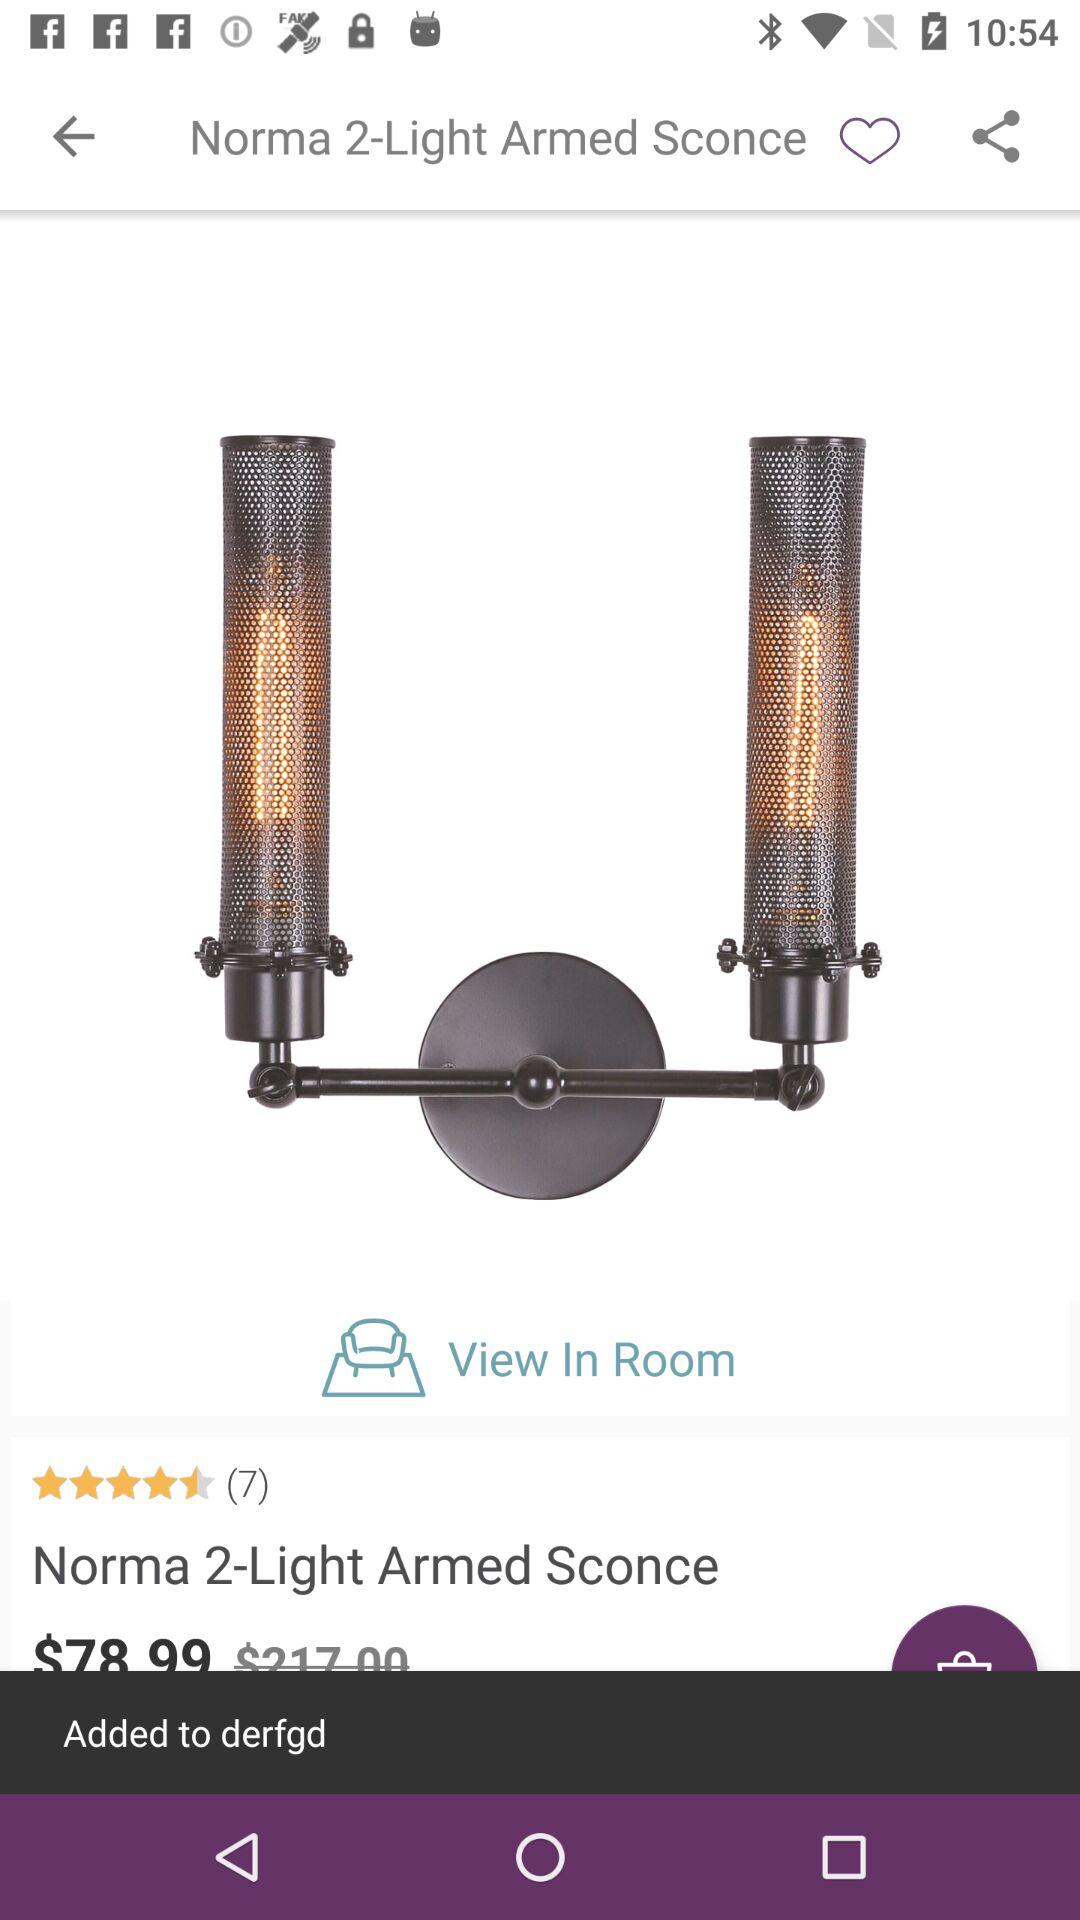What is the price?
When the provided information is insufficient, respond with <no answer>. <no answer> 